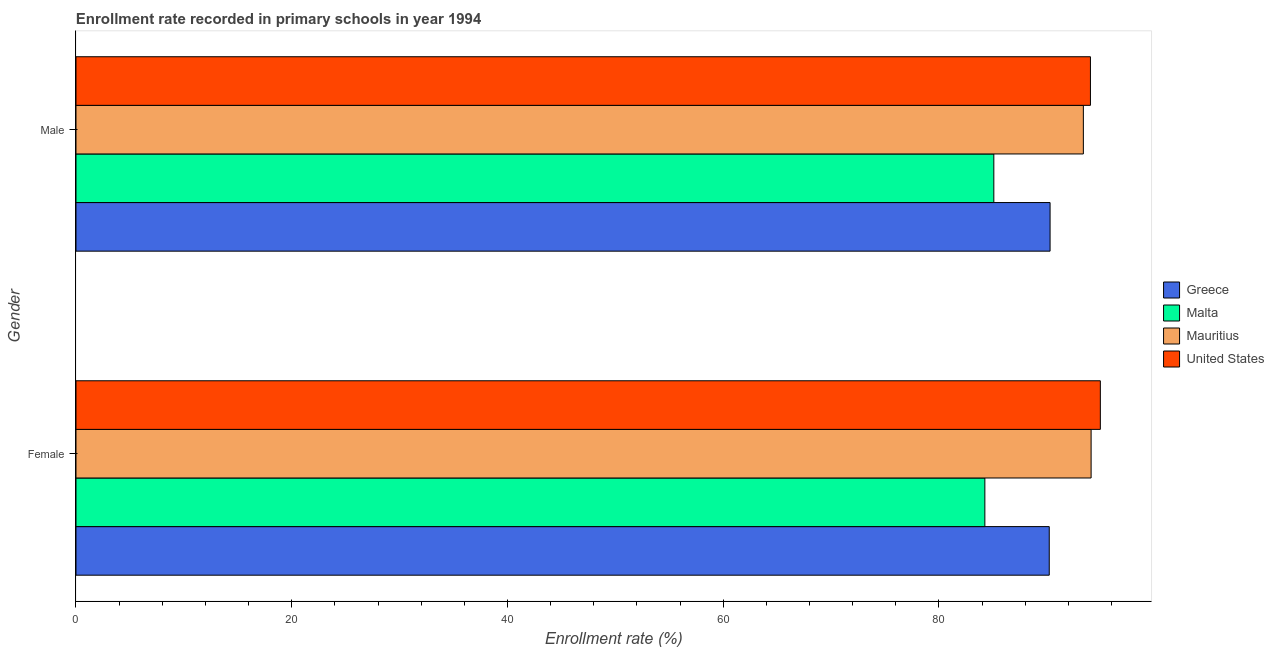How many different coloured bars are there?
Provide a succinct answer. 4. How many groups of bars are there?
Ensure brevity in your answer.  2. Are the number of bars per tick equal to the number of legend labels?
Keep it short and to the point. Yes. Are the number of bars on each tick of the Y-axis equal?
Offer a very short reply. Yes. What is the label of the 1st group of bars from the top?
Provide a succinct answer. Male. What is the enrollment rate of female students in Malta?
Your response must be concise. 84.26. Across all countries, what is the maximum enrollment rate of female students?
Your answer should be compact. 94.97. Across all countries, what is the minimum enrollment rate of male students?
Provide a succinct answer. 85.09. In which country was the enrollment rate of male students minimum?
Keep it short and to the point. Malta. What is the total enrollment rate of male students in the graph?
Offer a terse response. 362.83. What is the difference between the enrollment rate of female students in United States and that in Malta?
Offer a terse response. 10.71. What is the difference between the enrollment rate of male students in Greece and the enrollment rate of female students in United States?
Provide a short and direct response. -4.66. What is the average enrollment rate of male students per country?
Ensure brevity in your answer.  90.71. What is the difference between the enrollment rate of female students and enrollment rate of male students in Malta?
Make the answer very short. -0.83. What is the ratio of the enrollment rate of male students in United States to that in Greece?
Keep it short and to the point. 1.04. In how many countries, is the enrollment rate of male students greater than the average enrollment rate of male students taken over all countries?
Provide a succinct answer. 2. What does the 2nd bar from the top in Male represents?
Your answer should be very brief. Mauritius. What does the 2nd bar from the bottom in Female represents?
Ensure brevity in your answer.  Malta. Are all the bars in the graph horizontal?
Offer a very short reply. Yes. What is the difference between two consecutive major ticks on the X-axis?
Offer a very short reply. 20. Are the values on the major ticks of X-axis written in scientific E-notation?
Provide a short and direct response. No. Does the graph contain any zero values?
Offer a very short reply. No. Where does the legend appear in the graph?
Ensure brevity in your answer.  Center right. How are the legend labels stacked?
Ensure brevity in your answer.  Vertical. What is the title of the graph?
Make the answer very short. Enrollment rate recorded in primary schools in year 1994. What is the label or title of the X-axis?
Offer a very short reply. Enrollment rate (%). What is the label or title of the Y-axis?
Offer a very short reply. Gender. What is the Enrollment rate (%) in Greece in Female?
Offer a very short reply. 90.23. What is the Enrollment rate (%) of Malta in Female?
Provide a succinct answer. 84.26. What is the Enrollment rate (%) in Mauritius in Female?
Make the answer very short. 94.11. What is the Enrollment rate (%) in United States in Female?
Give a very brief answer. 94.97. What is the Enrollment rate (%) of Greece in Male?
Offer a terse response. 90.31. What is the Enrollment rate (%) of Malta in Male?
Keep it short and to the point. 85.09. What is the Enrollment rate (%) in Mauritius in Male?
Give a very brief answer. 93.39. What is the Enrollment rate (%) in United States in Male?
Ensure brevity in your answer.  94.05. Across all Gender, what is the maximum Enrollment rate (%) in Greece?
Make the answer very short. 90.31. Across all Gender, what is the maximum Enrollment rate (%) in Malta?
Give a very brief answer. 85.09. Across all Gender, what is the maximum Enrollment rate (%) of Mauritius?
Your response must be concise. 94.11. Across all Gender, what is the maximum Enrollment rate (%) in United States?
Give a very brief answer. 94.97. Across all Gender, what is the minimum Enrollment rate (%) in Greece?
Provide a succinct answer. 90.23. Across all Gender, what is the minimum Enrollment rate (%) of Malta?
Make the answer very short. 84.26. Across all Gender, what is the minimum Enrollment rate (%) in Mauritius?
Offer a terse response. 93.39. Across all Gender, what is the minimum Enrollment rate (%) in United States?
Provide a short and direct response. 94.05. What is the total Enrollment rate (%) of Greece in the graph?
Your answer should be compact. 180.53. What is the total Enrollment rate (%) in Malta in the graph?
Offer a terse response. 169.35. What is the total Enrollment rate (%) of Mauritius in the graph?
Your response must be concise. 187.5. What is the total Enrollment rate (%) of United States in the graph?
Keep it short and to the point. 189.01. What is the difference between the Enrollment rate (%) of Greece in Female and that in Male?
Offer a very short reply. -0.08. What is the difference between the Enrollment rate (%) of Malta in Female and that in Male?
Your response must be concise. -0.83. What is the difference between the Enrollment rate (%) of Mauritius in Female and that in Male?
Ensure brevity in your answer.  0.72. What is the difference between the Enrollment rate (%) of United States in Female and that in Male?
Provide a short and direct response. 0.92. What is the difference between the Enrollment rate (%) in Greece in Female and the Enrollment rate (%) in Malta in Male?
Your response must be concise. 5.14. What is the difference between the Enrollment rate (%) in Greece in Female and the Enrollment rate (%) in Mauritius in Male?
Ensure brevity in your answer.  -3.16. What is the difference between the Enrollment rate (%) of Greece in Female and the Enrollment rate (%) of United States in Male?
Your answer should be very brief. -3.82. What is the difference between the Enrollment rate (%) of Malta in Female and the Enrollment rate (%) of Mauritius in Male?
Provide a short and direct response. -9.13. What is the difference between the Enrollment rate (%) in Malta in Female and the Enrollment rate (%) in United States in Male?
Keep it short and to the point. -9.79. What is the difference between the Enrollment rate (%) of Mauritius in Female and the Enrollment rate (%) of United States in Male?
Offer a terse response. 0.06. What is the average Enrollment rate (%) of Greece per Gender?
Your answer should be very brief. 90.27. What is the average Enrollment rate (%) of Malta per Gender?
Your answer should be compact. 84.68. What is the average Enrollment rate (%) of Mauritius per Gender?
Your response must be concise. 93.75. What is the average Enrollment rate (%) in United States per Gender?
Provide a short and direct response. 94.51. What is the difference between the Enrollment rate (%) in Greece and Enrollment rate (%) in Malta in Female?
Make the answer very short. 5.97. What is the difference between the Enrollment rate (%) of Greece and Enrollment rate (%) of Mauritius in Female?
Keep it short and to the point. -3.88. What is the difference between the Enrollment rate (%) of Greece and Enrollment rate (%) of United States in Female?
Keep it short and to the point. -4.74. What is the difference between the Enrollment rate (%) in Malta and Enrollment rate (%) in Mauritius in Female?
Make the answer very short. -9.85. What is the difference between the Enrollment rate (%) of Malta and Enrollment rate (%) of United States in Female?
Offer a terse response. -10.71. What is the difference between the Enrollment rate (%) in Mauritius and Enrollment rate (%) in United States in Female?
Ensure brevity in your answer.  -0.86. What is the difference between the Enrollment rate (%) in Greece and Enrollment rate (%) in Malta in Male?
Provide a succinct answer. 5.22. What is the difference between the Enrollment rate (%) in Greece and Enrollment rate (%) in Mauritius in Male?
Provide a short and direct response. -3.09. What is the difference between the Enrollment rate (%) in Greece and Enrollment rate (%) in United States in Male?
Make the answer very short. -3.74. What is the difference between the Enrollment rate (%) of Malta and Enrollment rate (%) of Mauritius in Male?
Ensure brevity in your answer.  -8.3. What is the difference between the Enrollment rate (%) in Malta and Enrollment rate (%) in United States in Male?
Offer a very short reply. -8.96. What is the difference between the Enrollment rate (%) of Mauritius and Enrollment rate (%) of United States in Male?
Provide a succinct answer. -0.66. What is the ratio of the Enrollment rate (%) in Malta in Female to that in Male?
Provide a short and direct response. 0.99. What is the ratio of the Enrollment rate (%) in Mauritius in Female to that in Male?
Ensure brevity in your answer.  1.01. What is the ratio of the Enrollment rate (%) of United States in Female to that in Male?
Give a very brief answer. 1.01. What is the difference between the highest and the second highest Enrollment rate (%) of Greece?
Offer a very short reply. 0.08. What is the difference between the highest and the second highest Enrollment rate (%) in Malta?
Provide a succinct answer. 0.83. What is the difference between the highest and the second highest Enrollment rate (%) in Mauritius?
Offer a very short reply. 0.72. What is the difference between the highest and the second highest Enrollment rate (%) in United States?
Provide a short and direct response. 0.92. What is the difference between the highest and the lowest Enrollment rate (%) in Greece?
Provide a short and direct response. 0.08. What is the difference between the highest and the lowest Enrollment rate (%) of Malta?
Provide a short and direct response. 0.83. What is the difference between the highest and the lowest Enrollment rate (%) in Mauritius?
Give a very brief answer. 0.72. What is the difference between the highest and the lowest Enrollment rate (%) in United States?
Provide a short and direct response. 0.92. 